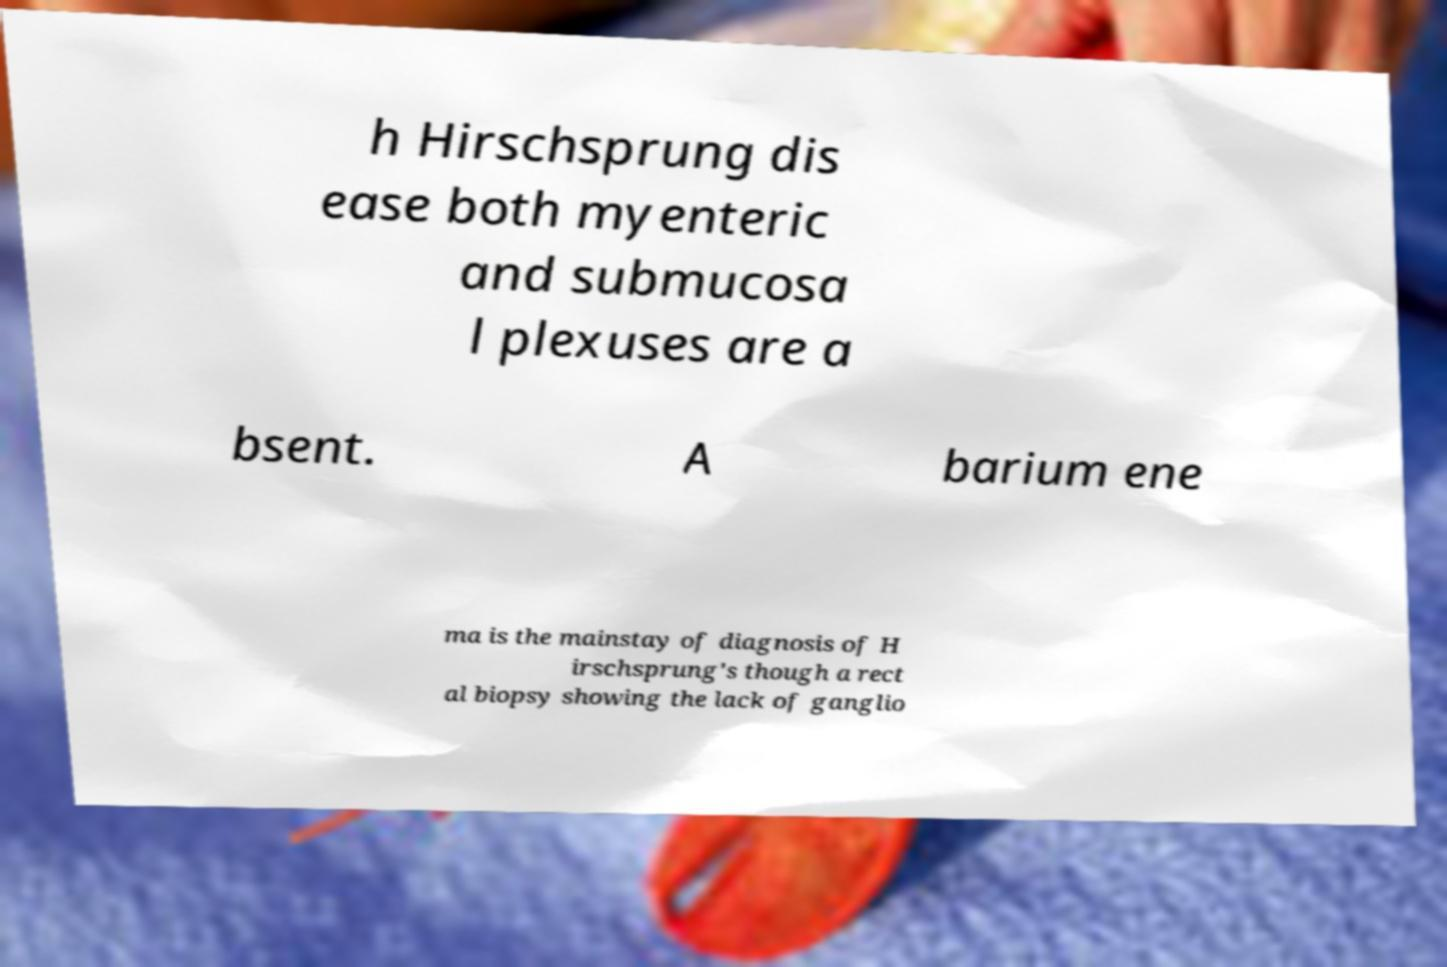What messages or text are displayed in this image? I need them in a readable, typed format. h Hirschsprung dis ease both myenteric and submucosa l plexuses are a bsent. A barium ene ma is the mainstay of diagnosis of H irschsprung's though a rect al biopsy showing the lack of ganglio 